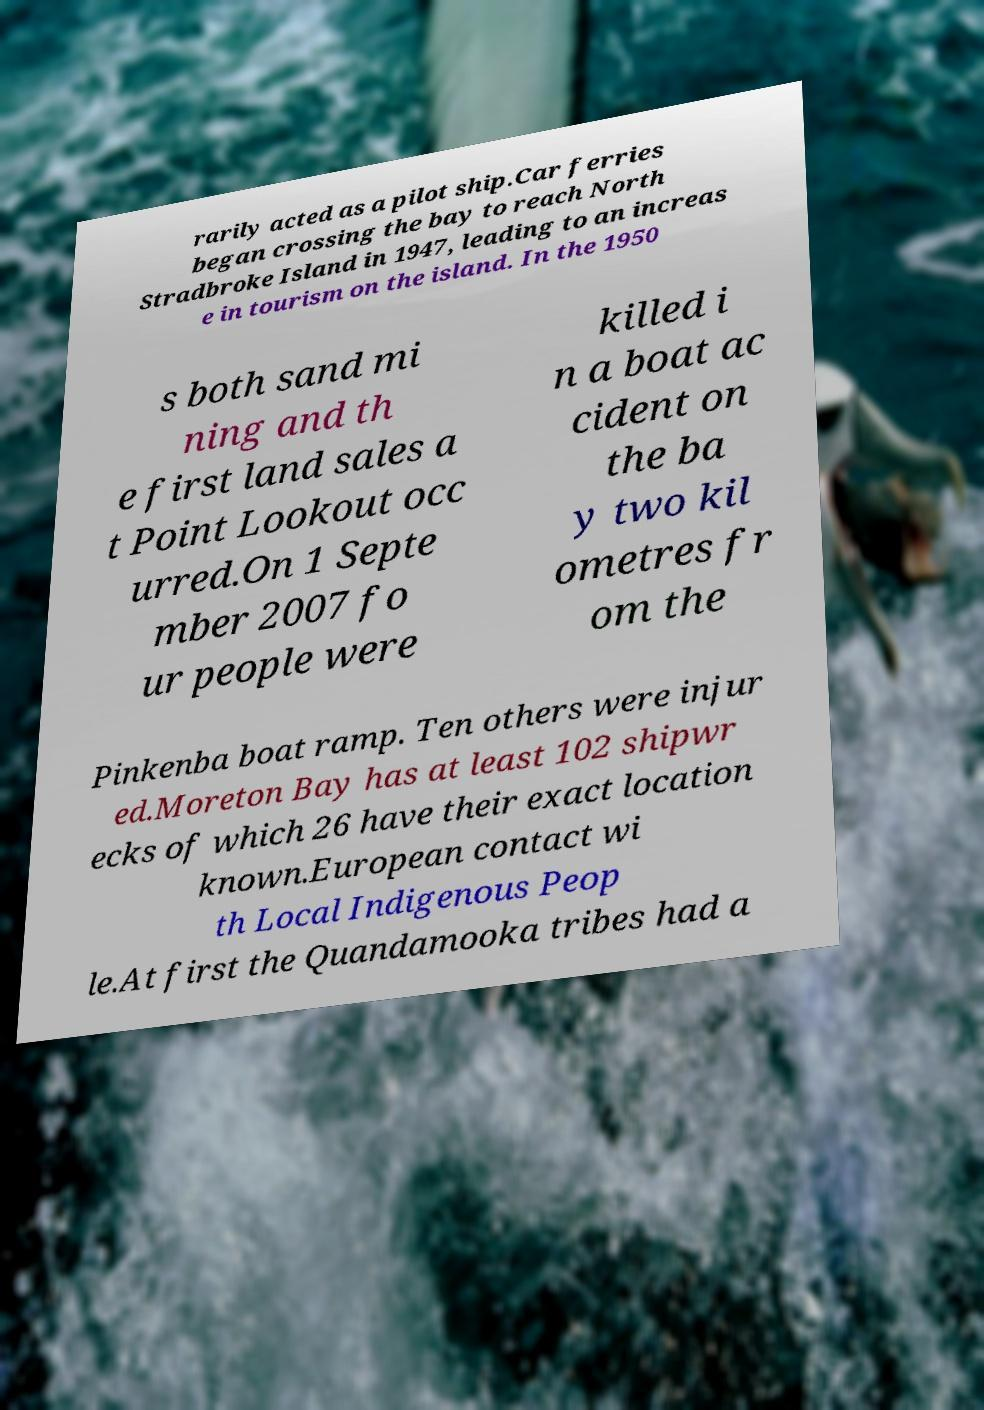What messages or text are displayed in this image? I need them in a readable, typed format. rarily acted as a pilot ship.Car ferries began crossing the bay to reach North Stradbroke Island in 1947, leading to an increas e in tourism on the island. In the 1950 s both sand mi ning and th e first land sales a t Point Lookout occ urred.On 1 Septe mber 2007 fo ur people were killed i n a boat ac cident on the ba y two kil ometres fr om the Pinkenba boat ramp. Ten others were injur ed.Moreton Bay has at least 102 shipwr ecks of which 26 have their exact location known.European contact wi th Local Indigenous Peop le.At first the Quandamooka tribes had a 